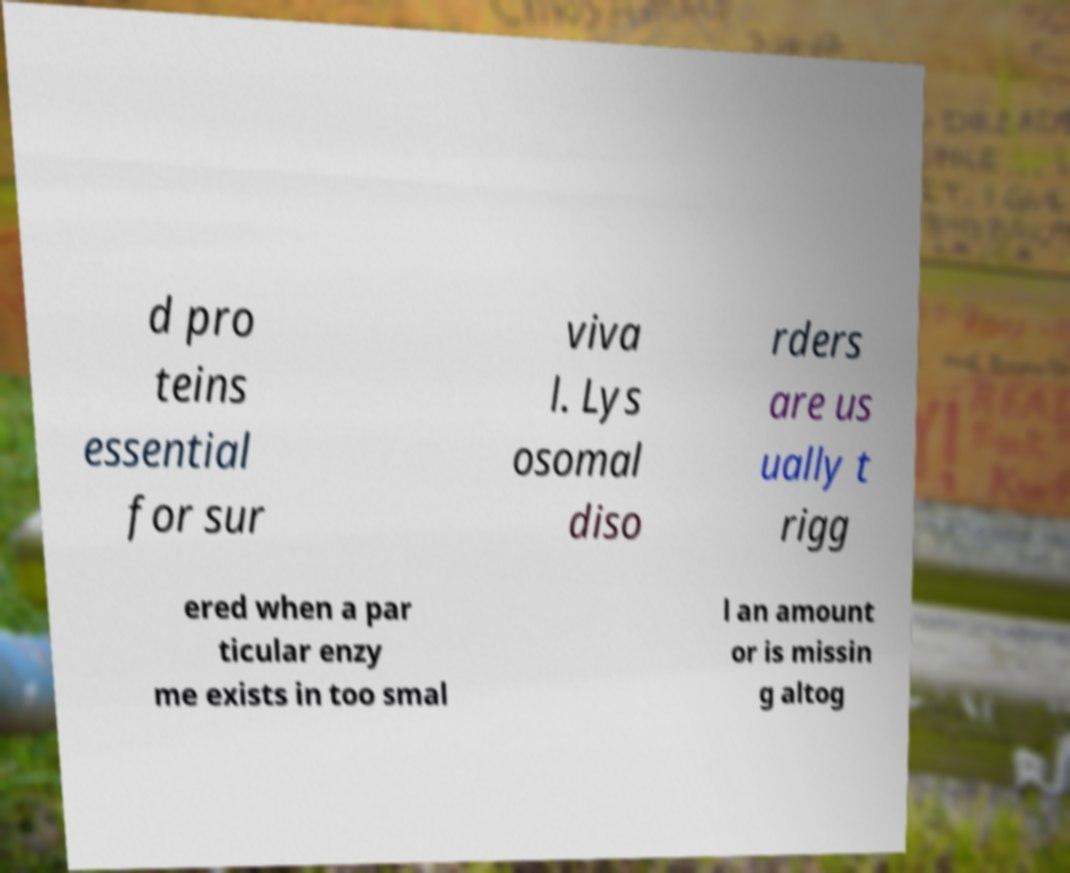There's text embedded in this image that I need extracted. Can you transcribe it verbatim? d pro teins essential for sur viva l. Lys osomal diso rders are us ually t rigg ered when a par ticular enzy me exists in too smal l an amount or is missin g altog 